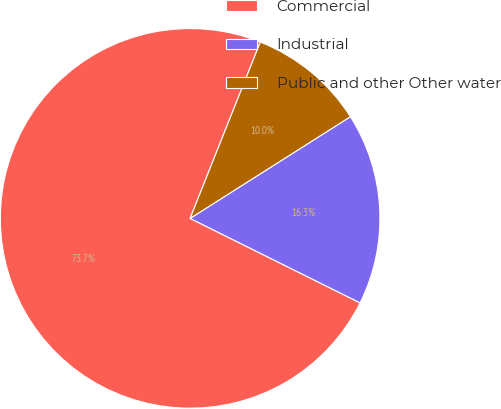Convert chart. <chart><loc_0><loc_0><loc_500><loc_500><pie_chart><fcel>Commercial<fcel>Industrial<fcel>Public and other Other water<nl><fcel>73.69%<fcel>16.34%<fcel>9.97%<nl></chart> 